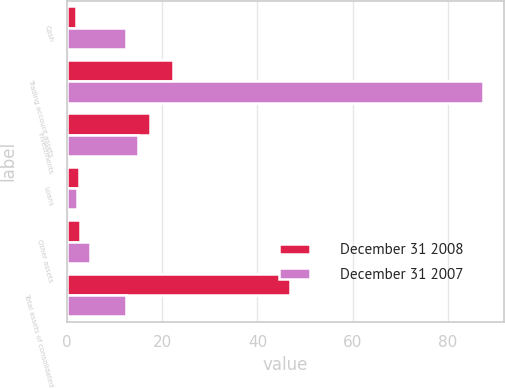<chart> <loc_0><loc_0><loc_500><loc_500><stacked_bar_chart><ecel><fcel>Cash<fcel>Trading account assets<fcel>Investments<fcel>Loans<fcel>Other assets<fcel>Total assets of consolidated<nl><fcel>December 31 2008<fcel>1.9<fcel>22.2<fcel>17.5<fcel>2.6<fcel>2.7<fcel>46.9<nl><fcel>December 31 2007<fcel>12.3<fcel>87.3<fcel>15<fcel>2.2<fcel>4.8<fcel>12.3<nl></chart> 